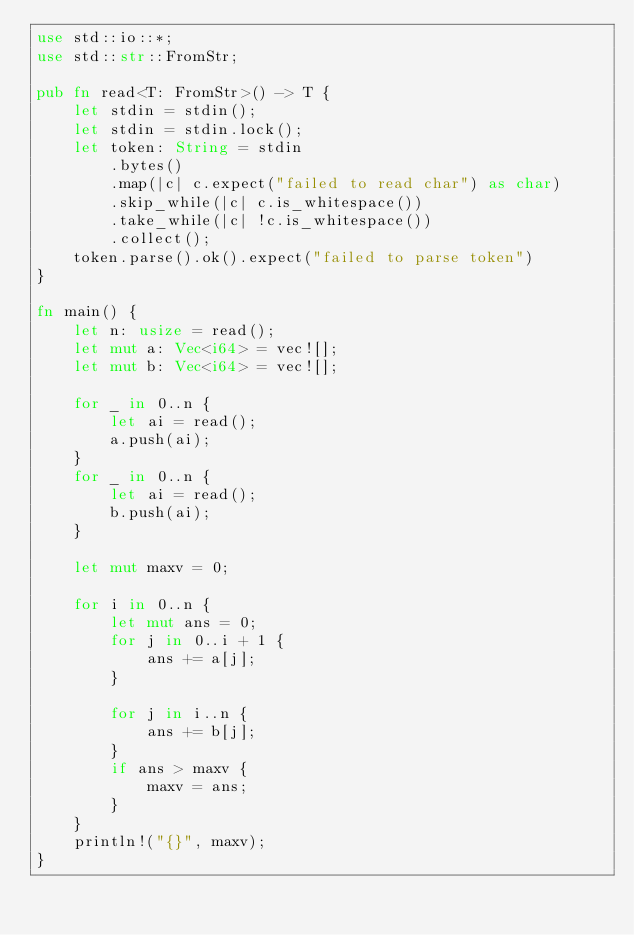<code> <loc_0><loc_0><loc_500><loc_500><_Rust_>use std::io::*;
use std::str::FromStr;

pub fn read<T: FromStr>() -> T {
    let stdin = stdin();
    let stdin = stdin.lock();
    let token: String = stdin
        .bytes()
        .map(|c| c.expect("failed to read char") as char)
        .skip_while(|c| c.is_whitespace())
        .take_while(|c| !c.is_whitespace())
        .collect();
    token.parse().ok().expect("failed to parse token")
}

fn main() {
    let n: usize = read();
    let mut a: Vec<i64> = vec![];
    let mut b: Vec<i64> = vec![];

    for _ in 0..n {
        let ai = read();
        a.push(ai);
    }
    for _ in 0..n {
        let ai = read();
        b.push(ai);
    }

    let mut maxv = 0;

    for i in 0..n {
        let mut ans = 0;
        for j in 0..i + 1 {
            ans += a[j];
        }

        for j in i..n {
            ans += b[j];
        }
        if ans > maxv {
            maxv = ans;
        }
    }
    println!("{}", maxv);
}
</code> 